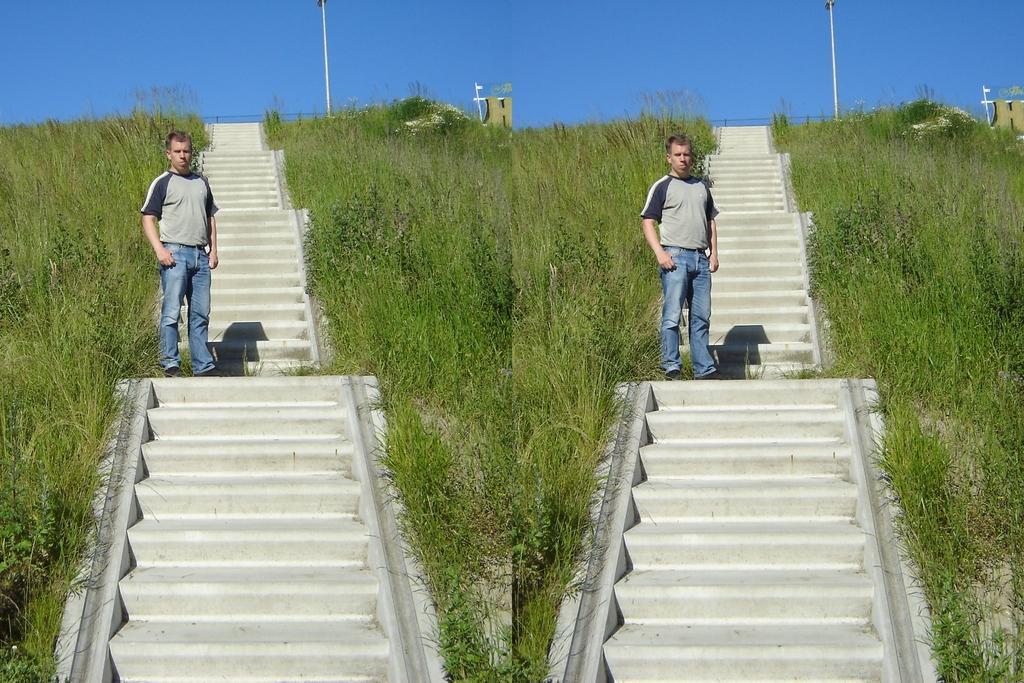Describe this image in one or two sentences. This is an edited image. Here I can see the same picture two times. Here I can see man standing on the stairs. On the both sides I can see the grass in green color. On the top of the image I can see the sky in blue color. 